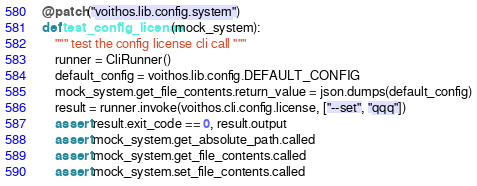Convert code to text. <code><loc_0><loc_0><loc_500><loc_500><_Python_>

@patch("voithos.lib.config.system")
def test_config_license(mock_system):
    """ test the config license cli call """
    runner = CliRunner()
    default_config = voithos.lib.config.DEFAULT_CONFIG
    mock_system.get_file_contents.return_value = json.dumps(default_config)
    result = runner.invoke(voithos.cli.config.license, ["--set", "qqq"])
    assert result.exit_code == 0, result.output
    assert mock_system.get_absolute_path.called
    assert mock_system.get_file_contents.called
    assert mock_system.set_file_contents.called
</code> 